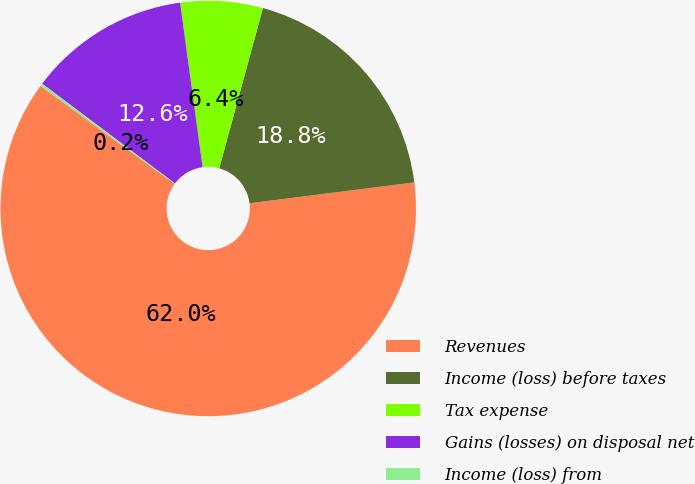Convert chart. <chart><loc_0><loc_0><loc_500><loc_500><pie_chart><fcel>Revenues<fcel>Income (loss) before taxes<fcel>Tax expense<fcel>Gains (losses) on disposal net<fcel>Income (loss) from<nl><fcel>62.05%<fcel>18.76%<fcel>6.4%<fcel>12.58%<fcel>0.21%<nl></chart> 